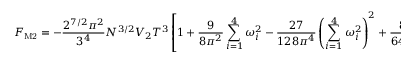<formula> <loc_0><loc_0><loc_500><loc_500>F _ { M 2 } = - \frac { 2 ^ { 7 / 2 } \pi ^ { 2 } } { 3 ^ { 4 } } N ^ { 3 / 2 } V _ { 2 } T ^ { 3 } \left [ 1 + \frac { 9 } { 8 \pi ^ { 2 } } \sum _ { i = 1 } ^ { 4 } \omega _ { i } ^ { 2 } - \frac { 2 7 } { 1 2 8 \pi ^ { 4 } } \left ( \sum _ { i = 1 } ^ { 4 } \omega _ { i } ^ { 2 } \right ) ^ { 2 } + \frac { 8 1 } { 6 4 \pi ^ { 4 } } \sum _ { i = 1 } ^ { 4 } \omega _ { i } ^ { 4 } + \dots \right ]</formula> 